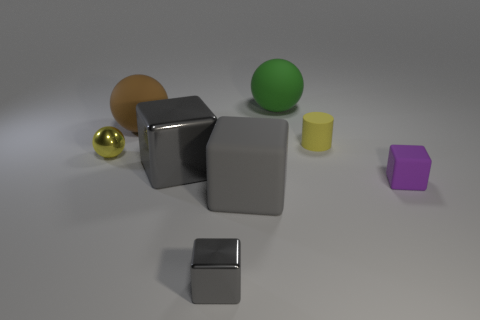There is a tiny thing behind the yellow shiny sphere; is it the same color as the tiny shiny thing behind the big rubber block?
Your response must be concise. Yes. How many metallic objects are big spheres or large brown objects?
Give a very brief answer. 0. What number of small yellow rubber cylinders are in front of the gray shiny cube that is behind the tiny shiny thing right of the small yellow shiny object?
Your answer should be compact. 0. There is a brown ball that is the same material as the green sphere; what size is it?
Offer a terse response. Large. What number of rubber objects are the same color as the shiny sphere?
Your answer should be compact. 1. There is a sphere in front of the brown object; is its size the same as the small cylinder?
Provide a succinct answer. Yes. What color is the big thing that is both to the left of the small gray object and behind the small yellow matte thing?
Your answer should be very brief. Brown. How many things are either shiny balls or metallic cubes behind the small gray metal object?
Your answer should be very brief. 2. What is the material of the block to the right of the big matte thing behind the big ball that is left of the tiny gray shiny block?
Your response must be concise. Rubber. Is the color of the large rubber thing in front of the matte cylinder the same as the large shiny cube?
Your answer should be compact. Yes. 